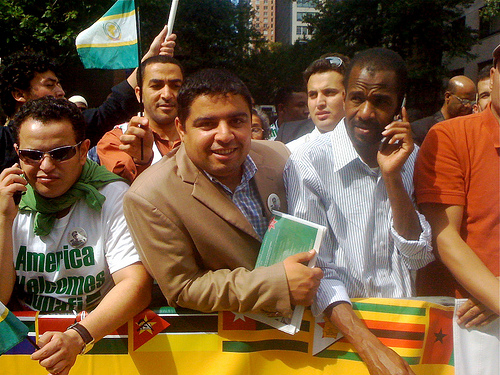Can you describe the people's clothing? The individuals in the image are dressed in casual attire. One person is wearing a white t-shirt with a printed design, another is in a light blue button-down shirt with a collar, and the third visible individual is wearing a dark suit jacket over a vertical-striped shirt. 